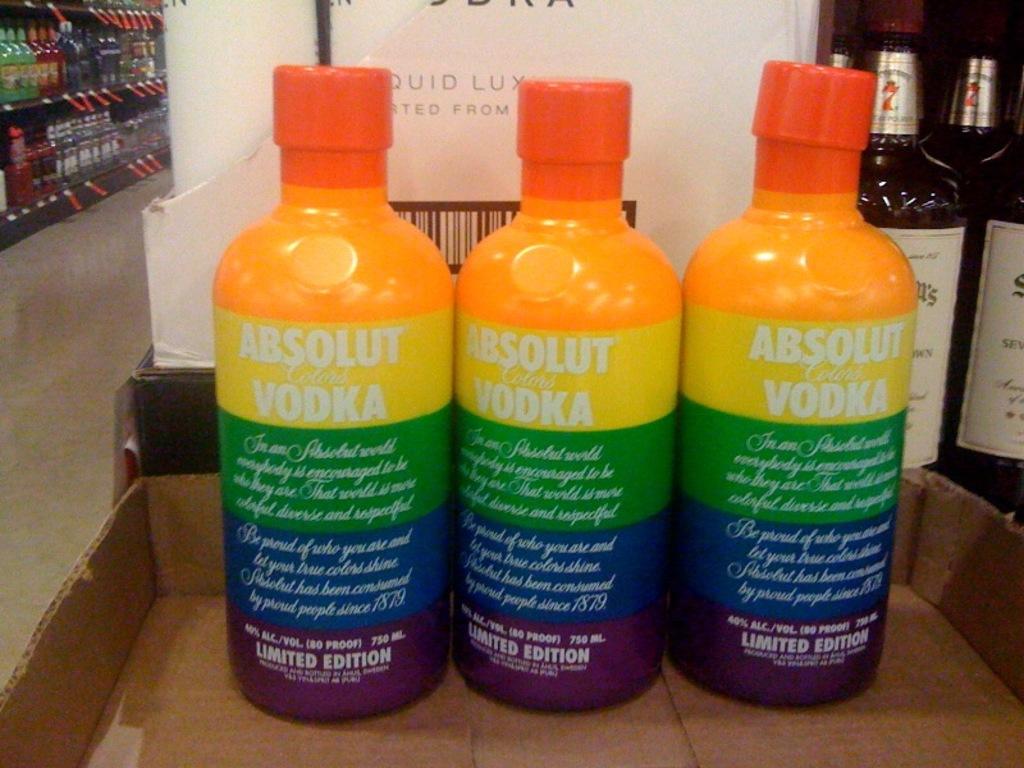What is the volume of these liquor bottles?
Keep it short and to the point. 750 ml. What kind of vodka is this?
Offer a very short reply. Absolut. 